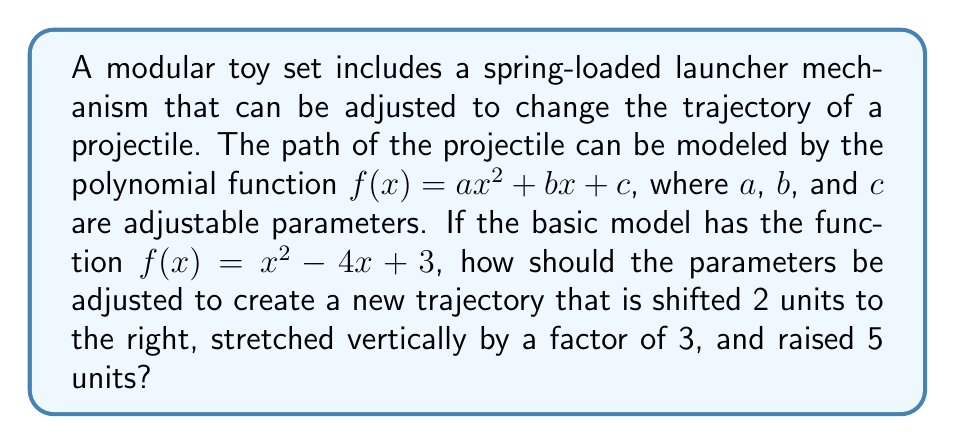Solve this math problem. Let's approach this step-by-step:

1) The original function is $f(x)=x^2-4x+3$

2) To shift the graph 2 units to the right, we replace every $x$ with $(x-2)$:
   $f(x)=(x-2)^2-4(x-2)+3$

3) Expanding this:
   $f(x)=x^2-4x+4-4x+8+3$
   $f(x)=x^2-8x+15$

4) To stretch vertically by a factor of 3, we multiply the entire function by 3:
   $f(x)=3(x^2-8x+15)$
   $f(x)=3x^2-24x+45$

5) To raise the graph 5 units, we add 5 to the function:
   $f(x)=3x^2-24x+45+5$
   $f(x)=3x^2-24x+50$

6) Comparing this to the general form $ax^2+bx+c$, we can identify:
   $a=3$
   $b=-24$
   $c=50$

Therefore, the parameters should be adjusted as follows:
- $a$ should be changed from 1 to 3
- $b$ should be changed from -4 to -24
- $c$ should be changed from 3 to 50
Answer: $a=3$, $b=-24$, $c=50$ 